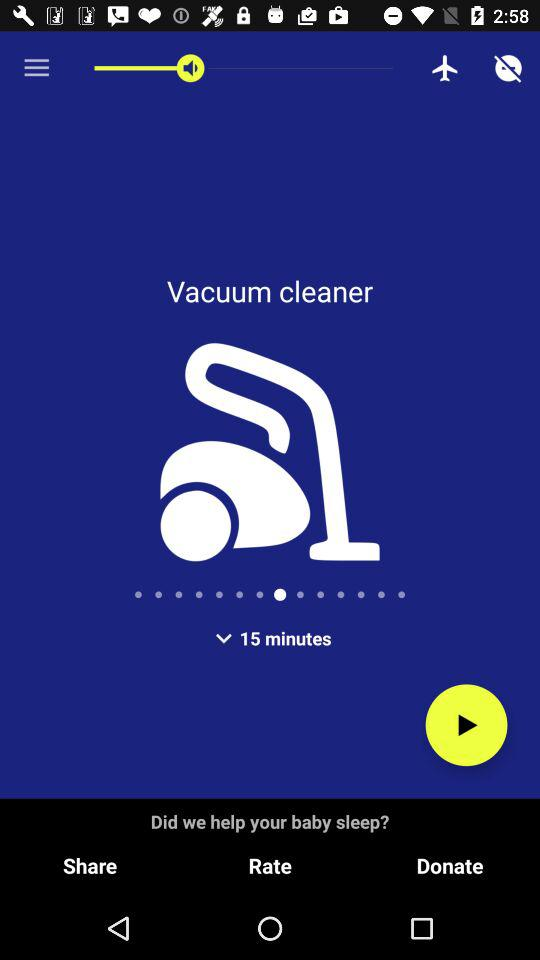What is the vacuum cleaner's set duration? The set duration is 15 minutes. 